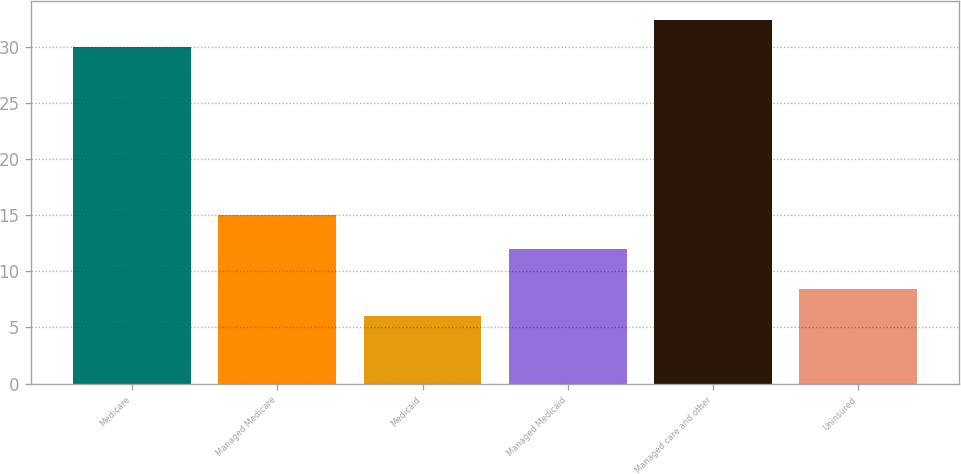<chart> <loc_0><loc_0><loc_500><loc_500><bar_chart><fcel>Medicare<fcel>Managed Medicare<fcel>Medicaid<fcel>Managed Medicaid<fcel>Managed care and other<fcel>Uninsured<nl><fcel>30<fcel>15<fcel>6<fcel>12<fcel>32.4<fcel>8.4<nl></chart> 